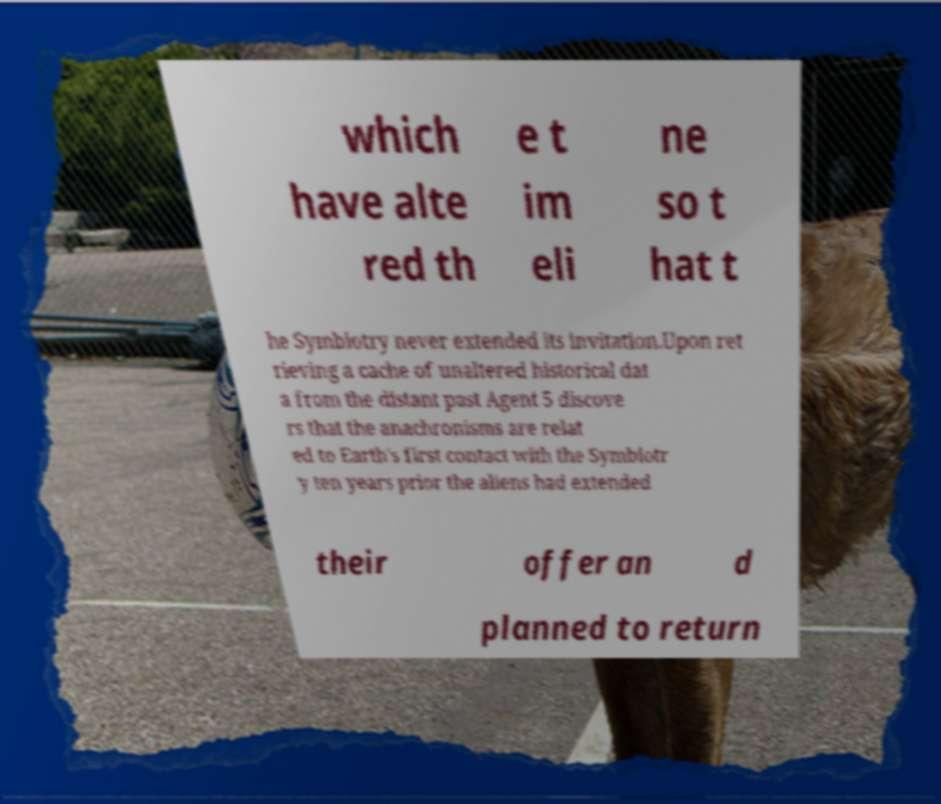For documentation purposes, I need the text within this image transcribed. Could you provide that? which have alte red th e t im eli ne so t hat t he Symbiotry never extended its invitation.Upon ret rieving a cache of unaltered historical dat a from the distant past Agent 5 discove rs that the anachronisms are relat ed to Earth's first contact with the Symbiotr y ten years prior the aliens had extended their offer an d planned to return 